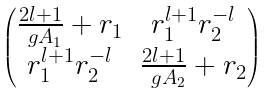<formula> <loc_0><loc_0><loc_500><loc_500>\begin{pmatrix} \frac { 2 l + 1 } { \ g A _ { 1 } } + r _ { 1 } & r _ { 1 } ^ { l + 1 } r _ { 2 } ^ { - l } \\ r _ { 1 } ^ { l + 1 } r _ { 2 } ^ { - l } & \frac { 2 l + 1 } { \ g A _ { 2 } } + r _ { 2 } \end{pmatrix}</formula> 